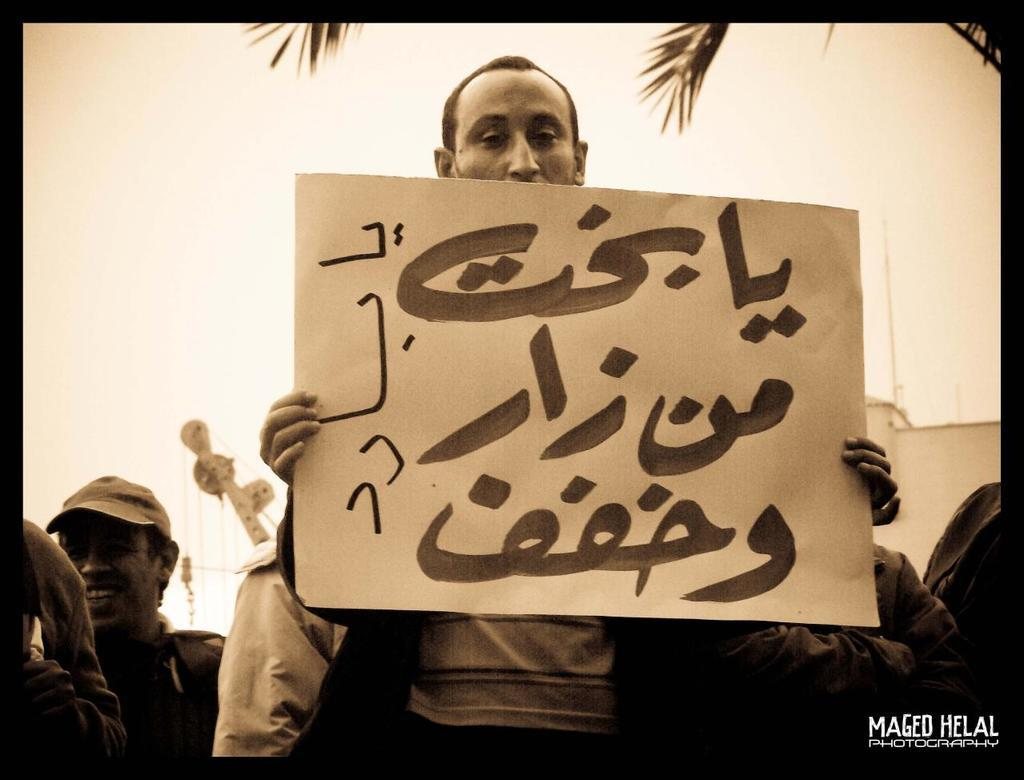What is the person in the image holding? The person is holding a paper in the image. Are there any other people visible in the image? Yes, there are other people behind the person holding the paper. What can be seen in the background of the image? There is a building and the sky visible in the background of the image. Is there any blood visible on the person holding the paper in the image? No, there is no blood visible in the image. 